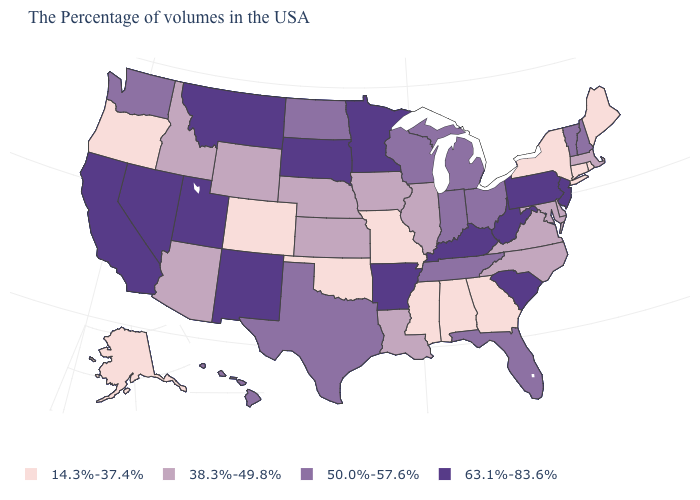Among the states that border Oklahoma , does Arkansas have the highest value?
Answer briefly. Yes. What is the value of Hawaii?
Short answer required. 50.0%-57.6%. What is the value of Maine?
Short answer required. 14.3%-37.4%. What is the value of California?
Give a very brief answer. 63.1%-83.6%. Name the states that have a value in the range 14.3%-37.4%?
Short answer required. Maine, Rhode Island, Connecticut, New York, Georgia, Alabama, Mississippi, Missouri, Oklahoma, Colorado, Oregon, Alaska. Name the states that have a value in the range 63.1%-83.6%?
Short answer required. New Jersey, Pennsylvania, South Carolina, West Virginia, Kentucky, Arkansas, Minnesota, South Dakota, New Mexico, Utah, Montana, Nevada, California. Does Oregon have a lower value than Alaska?
Keep it brief. No. Does Florida have a lower value than California?
Give a very brief answer. Yes. Does the first symbol in the legend represent the smallest category?
Keep it brief. Yes. Which states have the lowest value in the USA?
Give a very brief answer. Maine, Rhode Island, Connecticut, New York, Georgia, Alabama, Mississippi, Missouri, Oklahoma, Colorado, Oregon, Alaska. Name the states that have a value in the range 14.3%-37.4%?
Concise answer only. Maine, Rhode Island, Connecticut, New York, Georgia, Alabama, Mississippi, Missouri, Oklahoma, Colorado, Oregon, Alaska. What is the value of North Carolina?
Concise answer only. 38.3%-49.8%. How many symbols are there in the legend?
Give a very brief answer. 4. Does Rhode Island have a lower value than Maine?
Concise answer only. No. Which states hav the highest value in the MidWest?
Answer briefly. Minnesota, South Dakota. 